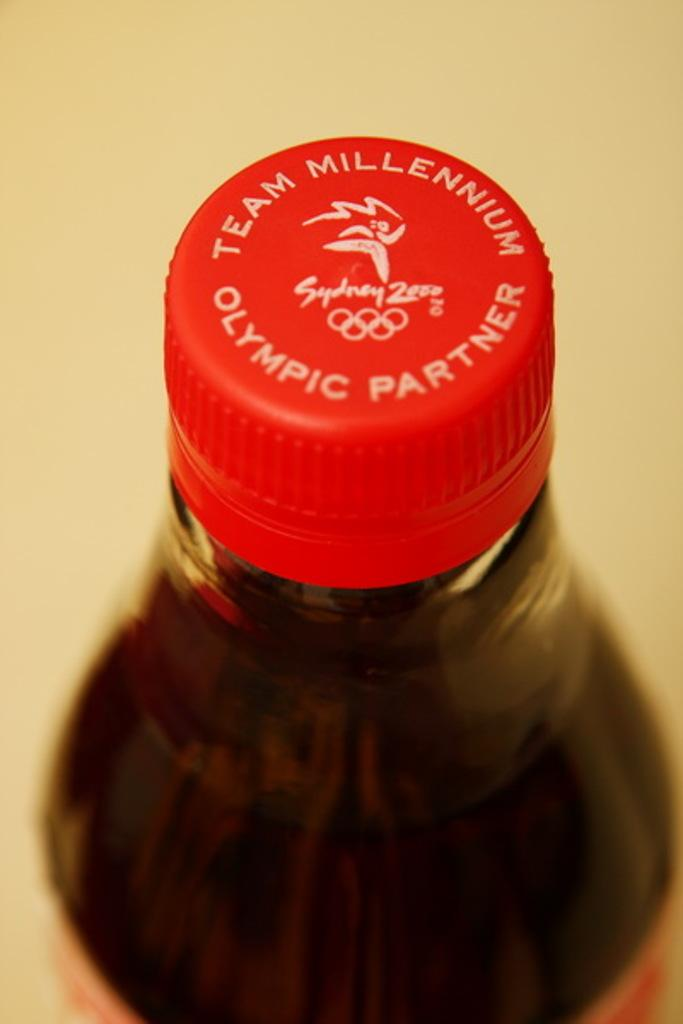<image>
Render a clear and concise summary of the photo. The top of a coke bottle with the words "Team Millennium Olympic  Partner" written on it's red cap. 